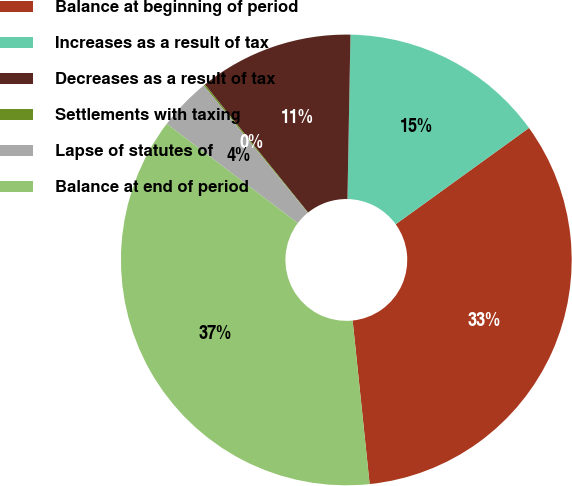Convert chart. <chart><loc_0><loc_0><loc_500><loc_500><pie_chart><fcel>Balance at beginning of period<fcel>Increases as a result of tax<fcel>Decreases as a result of tax<fcel>Settlements with taxing<fcel>Lapse of statutes of<fcel>Balance at end of period<nl><fcel>33.31%<fcel>14.75%<fcel>11.09%<fcel>0.11%<fcel>3.77%<fcel>36.97%<nl></chart> 